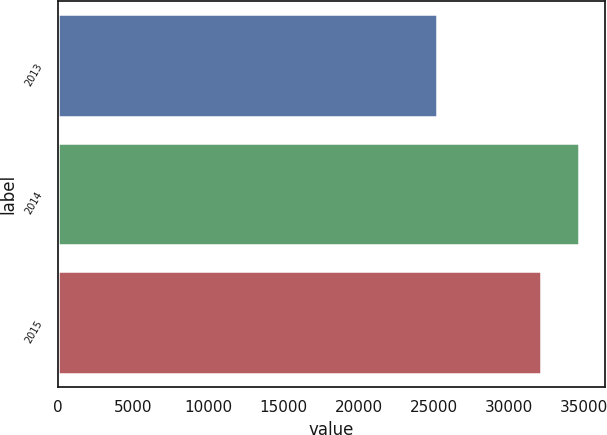<chart> <loc_0><loc_0><loc_500><loc_500><bar_chart><fcel>2013<fcel>2014<fcel>2015<nl><fcel>25209<fcel>34645<fcel>32141<nl></chart> 